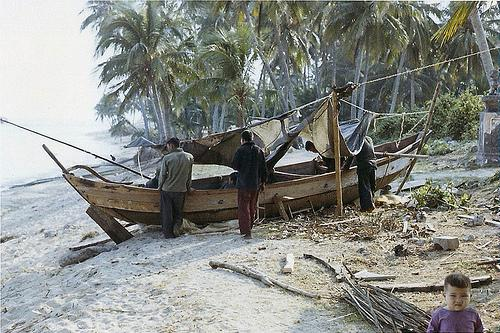Imagine you were there and narrate what you see. I'm standing on a serene beach, amid palm trees, observing three men working on a boat with a mesmerizing gray sail while a curious child in purple shirt gazes nearby. What are the key elements and objects in the image? Key elements include an old wooden boat, a group of trees, a child in a purple shirt, three men working on a sailboat, and a pile of firewood on the beach. What is the child wearing, and what is their location in the image? The child is wearing a purple shirt and is located near a group of trees, a bundle of firewood, and three men working on a sailboat. Provide a brief description of the scene depicted in the image. Three men are working on a sailboat near a group of palm trees on a beach, with a bundle of wood, a small boy in a purple shirt, and an old wooden boat nearby. Express the contents of the image in a poetic manner. A tranquil ocean rests beside a forest of palms, where men tend to sails and wooden vessels, and a young boy in purple dwells among the firewood. Describe the main objects and their colors in the image. Main objects are a boy in a purple shirt, a wooden boat, a group of men working on a sailboat with a gray sail, and a bundle of sticks on the white sand of the beach. Mention a few dominant colors present in the image. Dominant colors include purple, gray, light blue, brown, and white in the areas of a boy's shirt, a sail, water, boat, and sand. What are the people doing in the image, and where are they located? Three men are standing by a boat on the beach, working on the sail with a child wearing a purple shirt and a pile of sticks close by. Describe the wooden boat and its surroundings. The wooden boat is on the beach near calm water, white sand, a group of trees, a bundle of firewood, and three men working on a sailboat. What can you observe about the environment in the picture? The image environment includes a calm light blue body of water, white skies over the ocean, several palm trees near the beach, and white sand with firewood and a boat. 